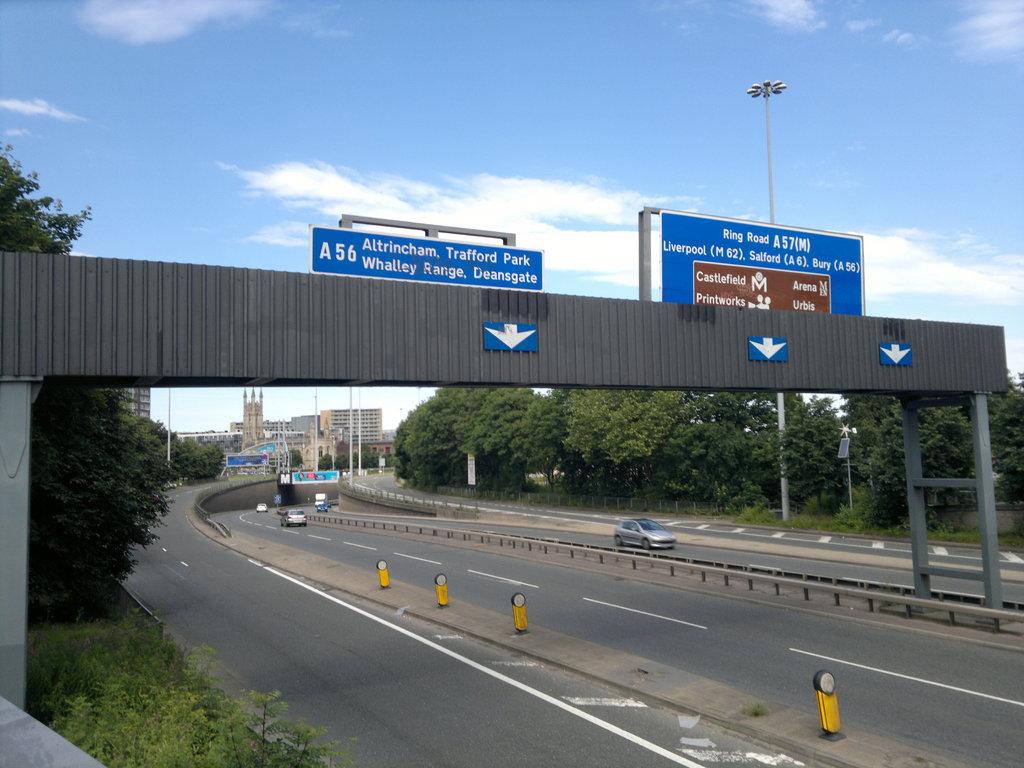What is the name of the exit?
Offer a very short reply. A56. 